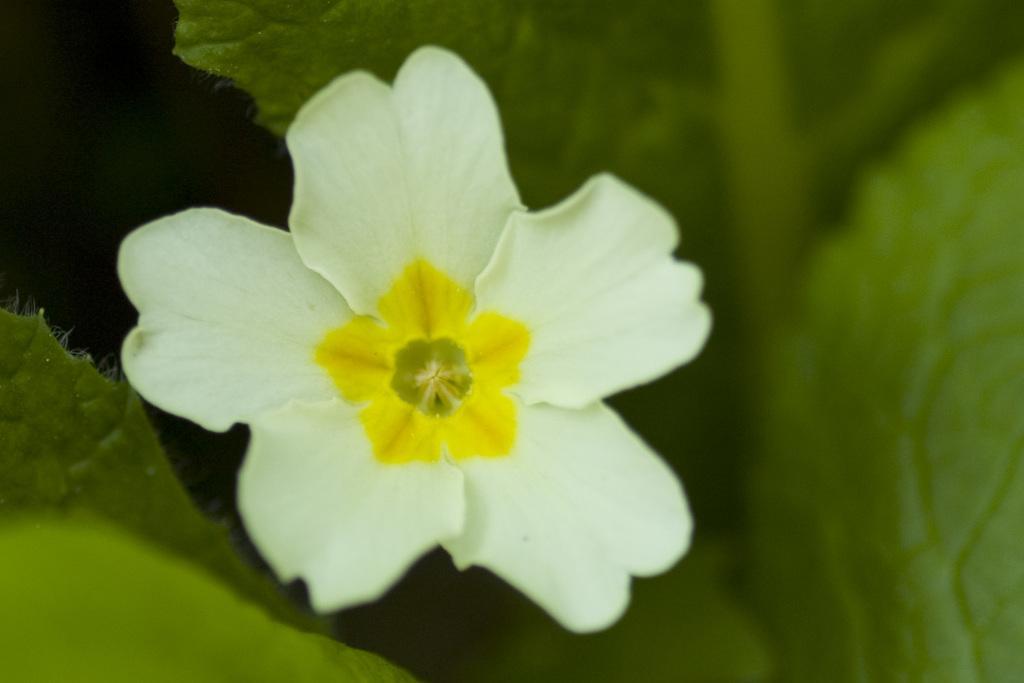Describe this image in one or two sentences. In the image we can see a flower, white and yellow in color and these are the leaves. 